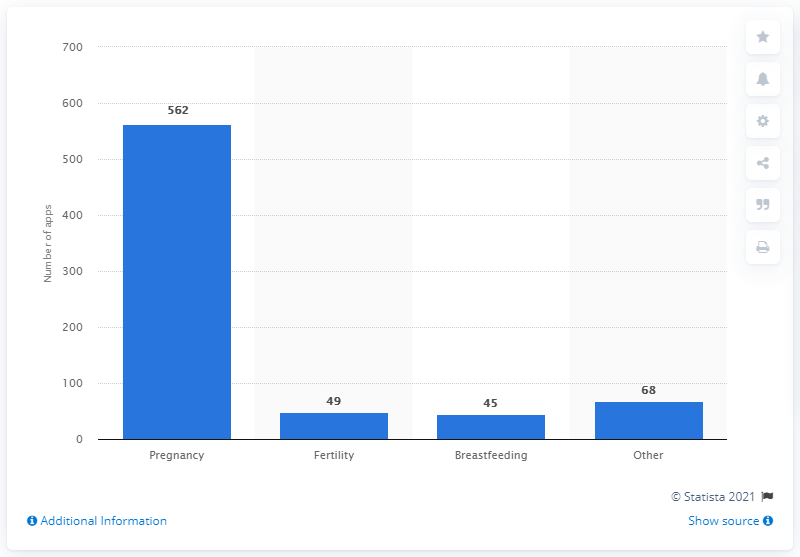Indicate a few pertinent items in this graphic. As of June 2013, there were 49 healthcare apps specifically designed for women's fertility issues. 